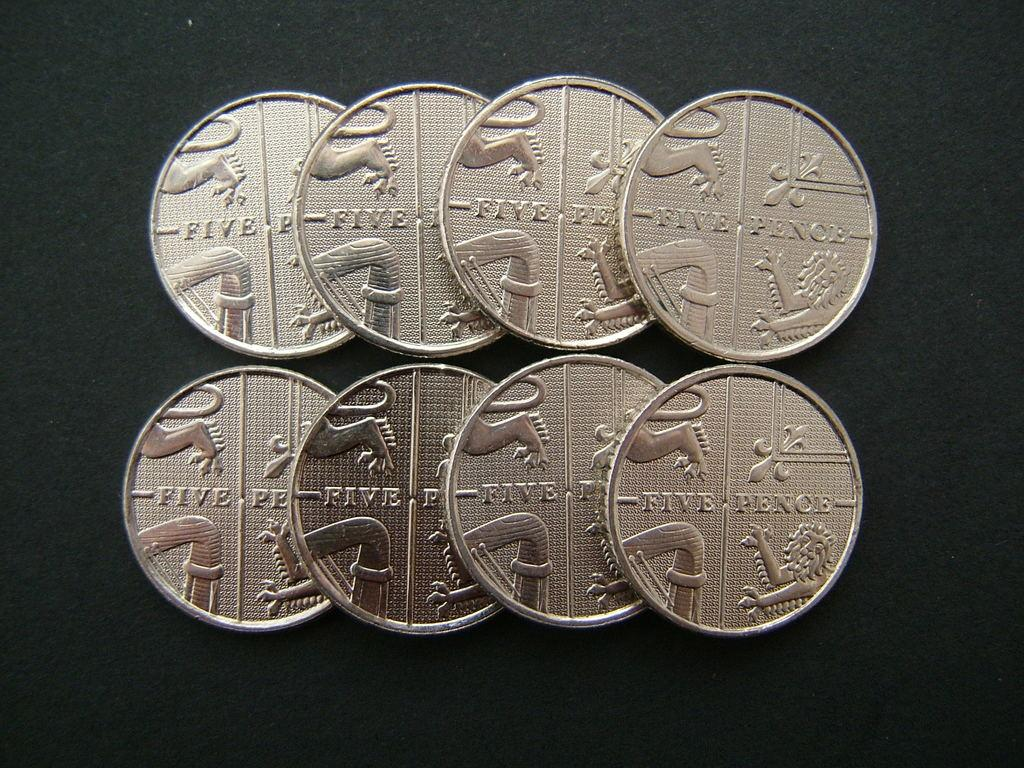<image>
Render a clear and concise summary of the photo. Two rows of silver five pence coins sit on a black background. 